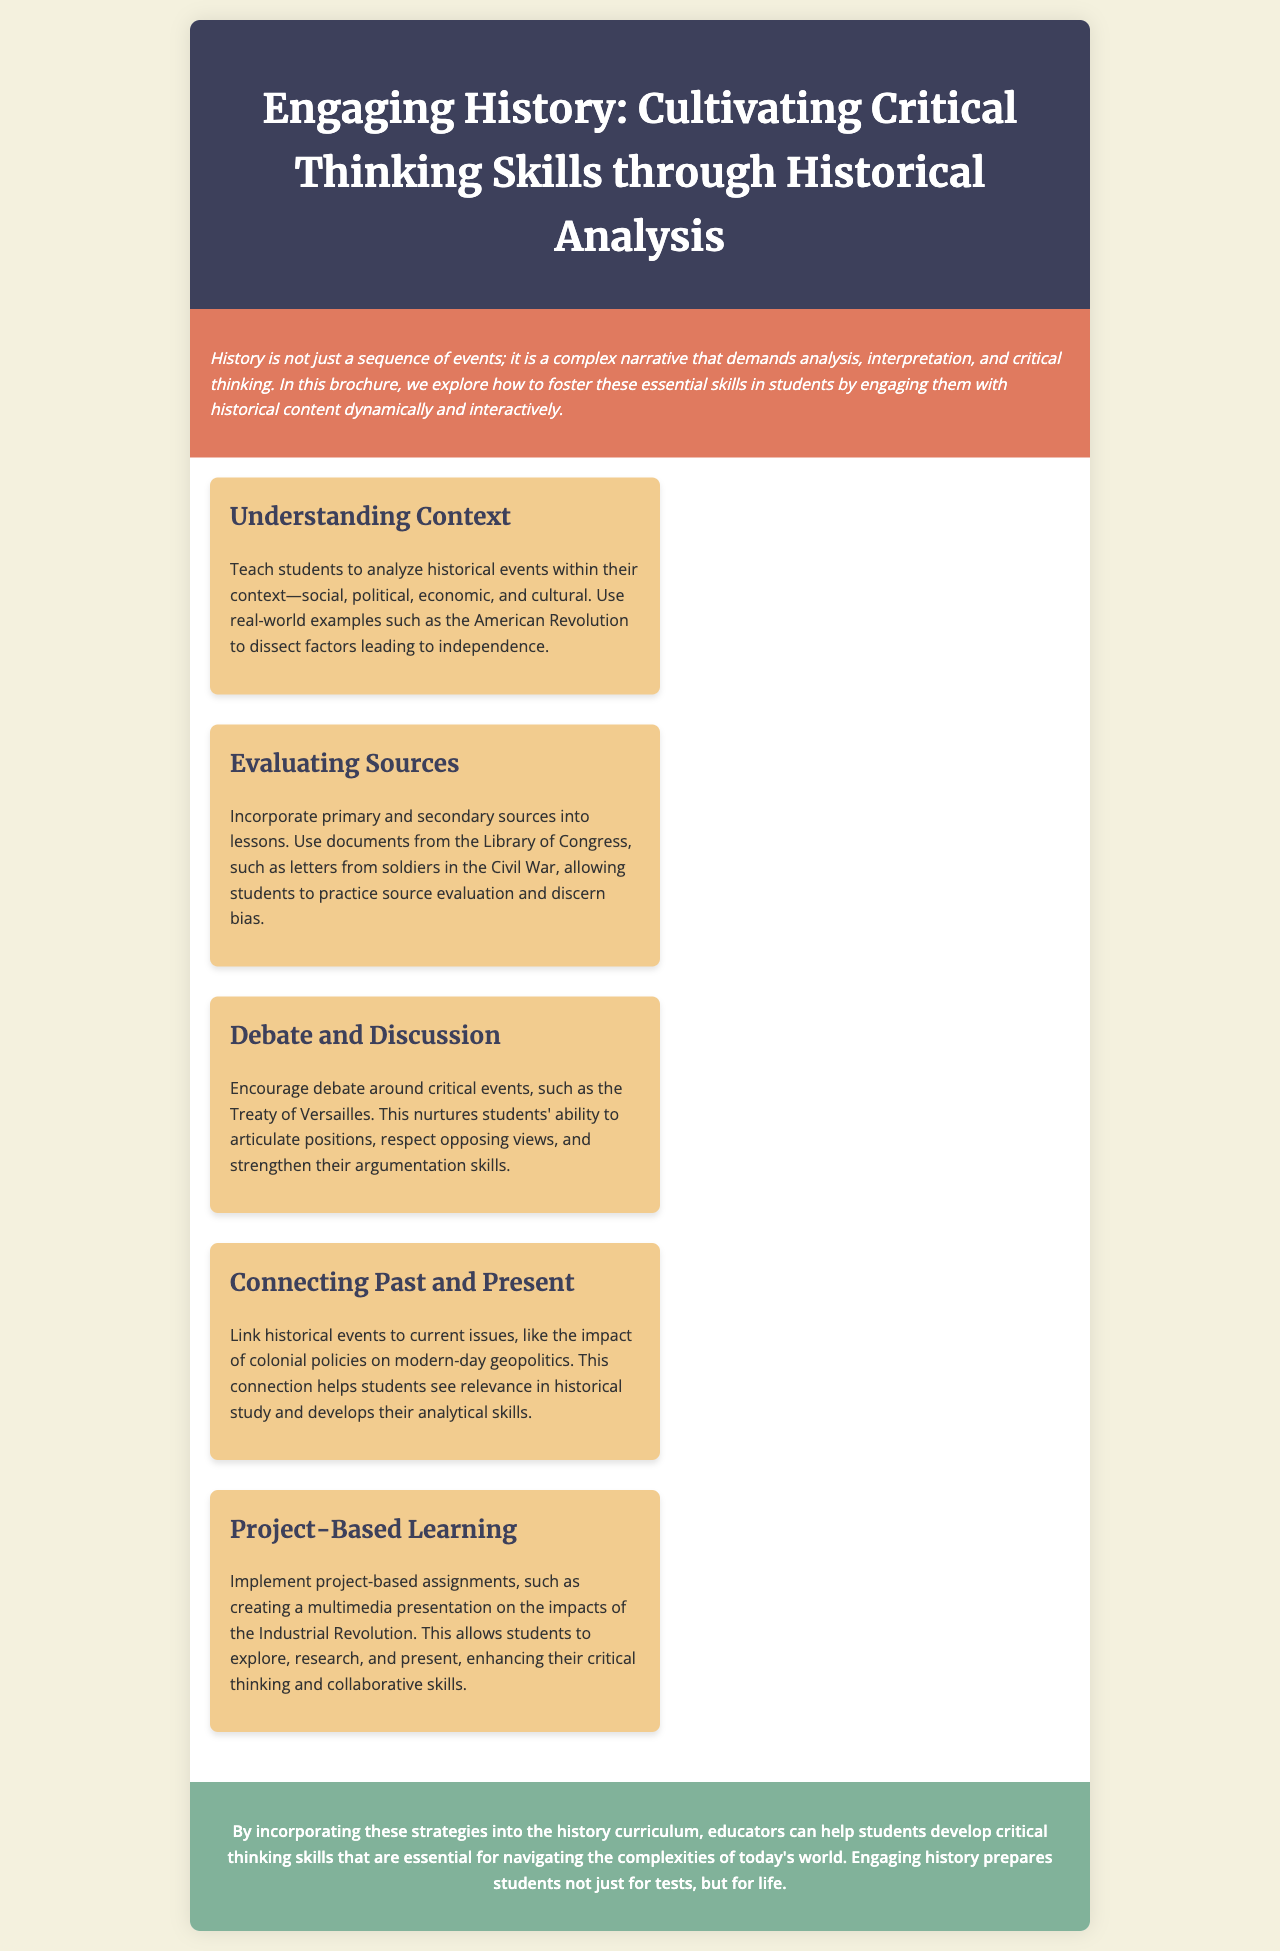What is the title of the brochure? The title is mentioned prominently at the top of the document, indicating the theme of the content.
Answer: Engaging History: Cultivating Critical Thinking Skills through Historical Analysis What is the background color of the header? The header background color is specified in the style section, which enhances its visual impact.
Answer: #3d405b Which historical event is used as an example for understanding context? The example is specifically mentioned in the context of teaching students to analyze historical events.
Answer: American Revolution What skill is nurtured through debate and discussion? The document outlines the outcome of engaging in discussions and debates within the history curriculum.
Answer: Argumentation skills What type of learning does the brochure recommend for enhancing critical thinking? The recommendation suggests a specific educational approach that encourages active learning through projects.
Answer: Project-Based Learning Which historic documents are suggested for evaluating sources? The document lists these sources to provide a practical approach to teaching evaluation.
Answer: Letters from soldiers in the Civil War What is one way to link historical events to current issues? The brochure mentions a specific method to demonstrate relevance between past and present situations.
Answer: Impact of colonial policies on modern-day geopolitics What section summarizes the importance of the strategies included? The conclusion section of the brochure encapsulates the main message about educating students for life.
Answer: Conclusion 